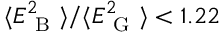Convert formula to latex. <formula><loc_0><loc_0><loc_500><loc_500>\langle E _ { B } ^ { 2 } \rangle / \langle E _ { G } ^ { 2 } \rangle < 1 . 2 2</formula> 